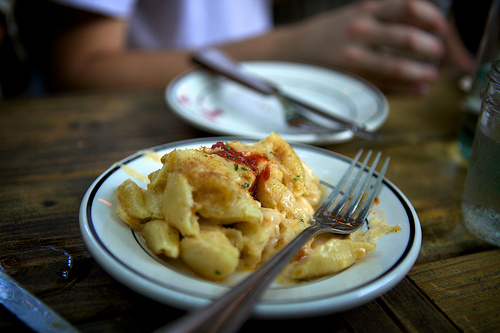<image>
Is there a food on the plate? Yes. Looking at the image, I can see the food is positioned on top of the plate, with the plate providing support. Is there a fork on the table? No. The fork is not positioned on the table. They may be near each other, but the fork is not supported by or resting on top of the table. Is the plate on the food? No. The plate is not positioned on the food. They may be near each other, but the plate is not supported by or resting on top of the food. 